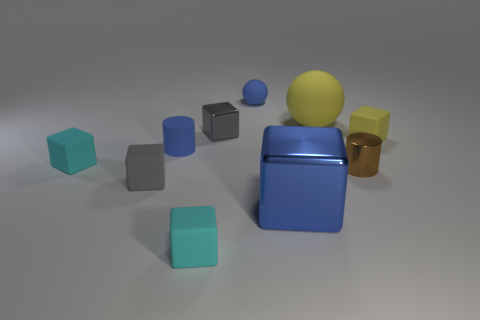There is a gray metallic object that is the same size as the yellow matte cube; what shape is it? The gray metallic object you're referring to is indeed shaped as a cube, sharing its form with the yellow matte cube. Both exhibit the characteristic six faces and twelve edges of a cube, making them geometrically identical. 